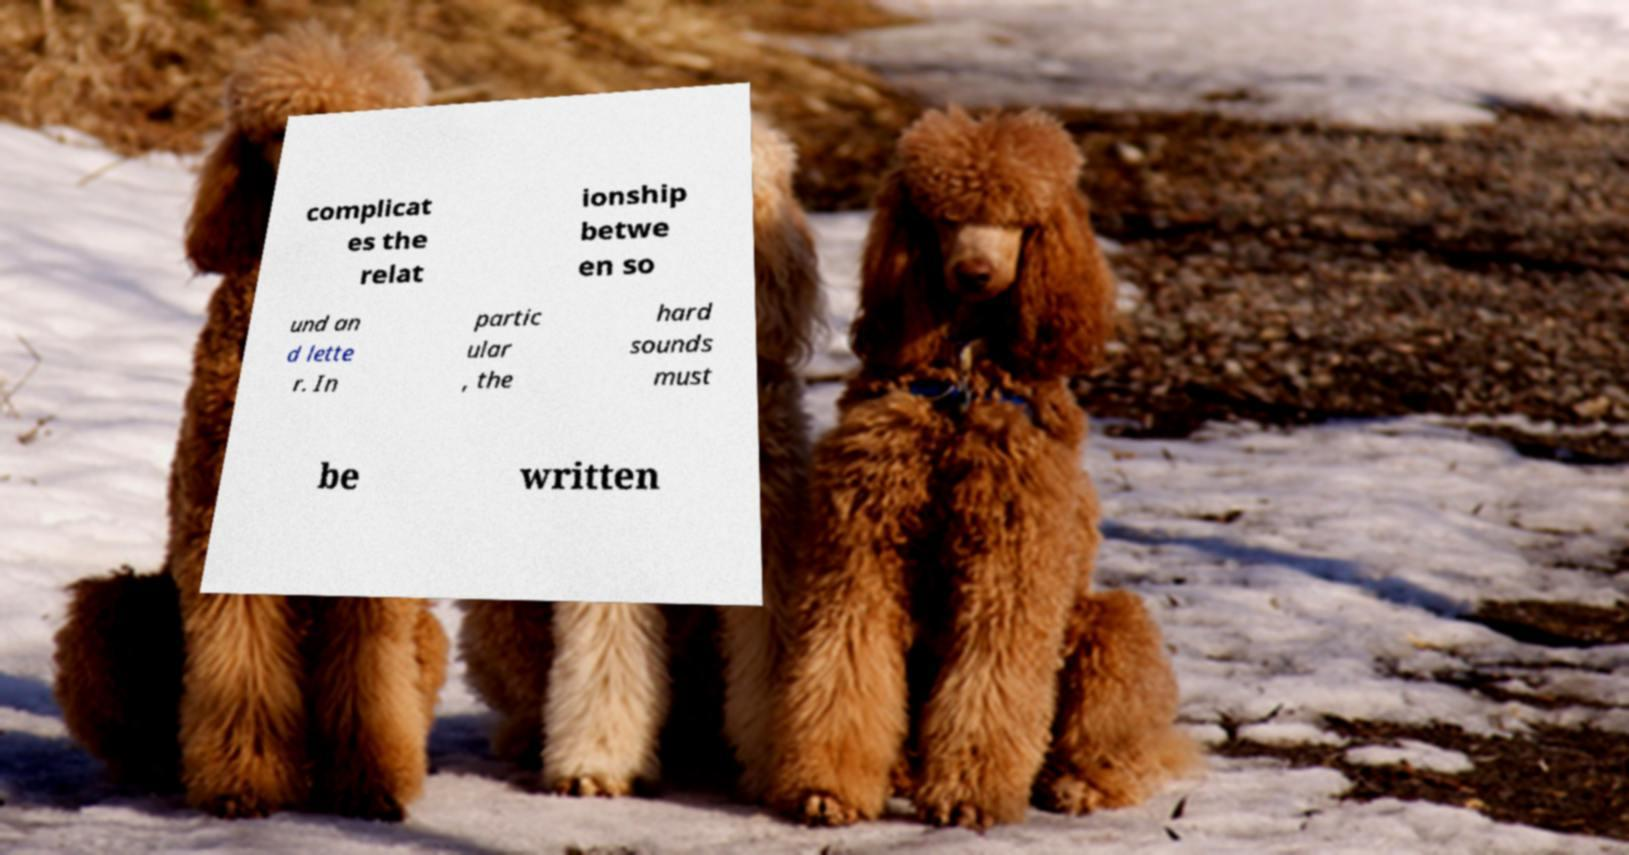Could you extract and type out the text from this image? complicat es the relat ionship betwe en so und an d lette r. In partic ular , the hard sounds must be written 